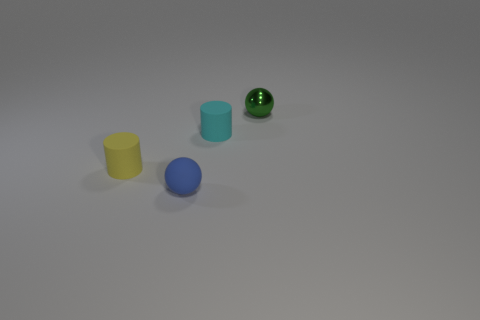What number of cyan objects are either rubber spheres or big cubes? There is one cyan object in the image, which is a big cube. There are no rubber spheres that are cyan in color. 